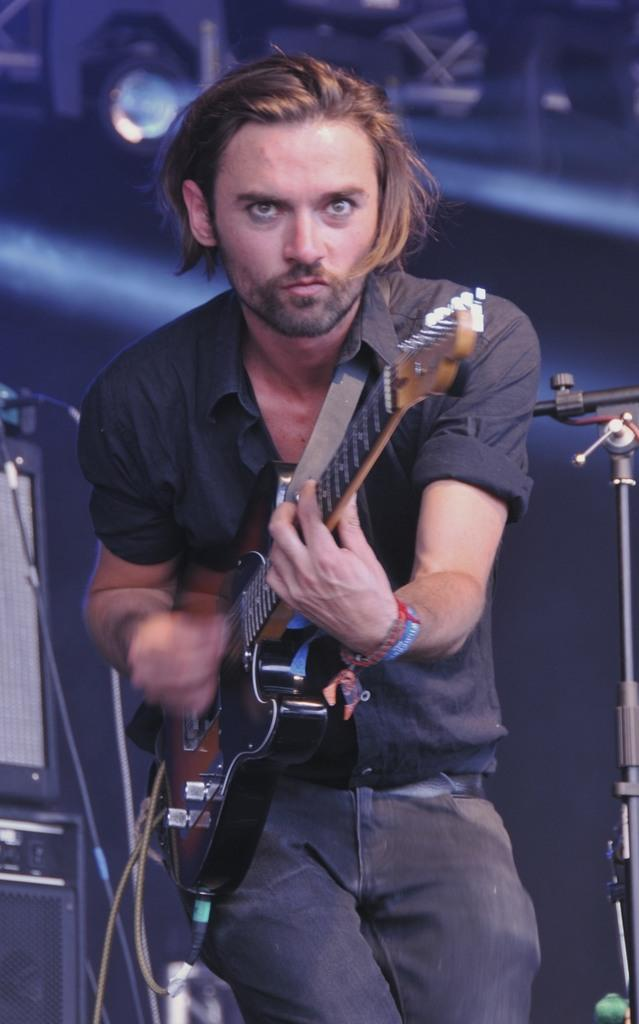What is the main subject of the image? The main subject of the image is a man. What is the man doing in the image? The man is standing and playing a guitar. What type of health benefits can be gained from playing the guitar in the image? The image does not provide information about health benefits, as it focuses on the man playing the guitar. 